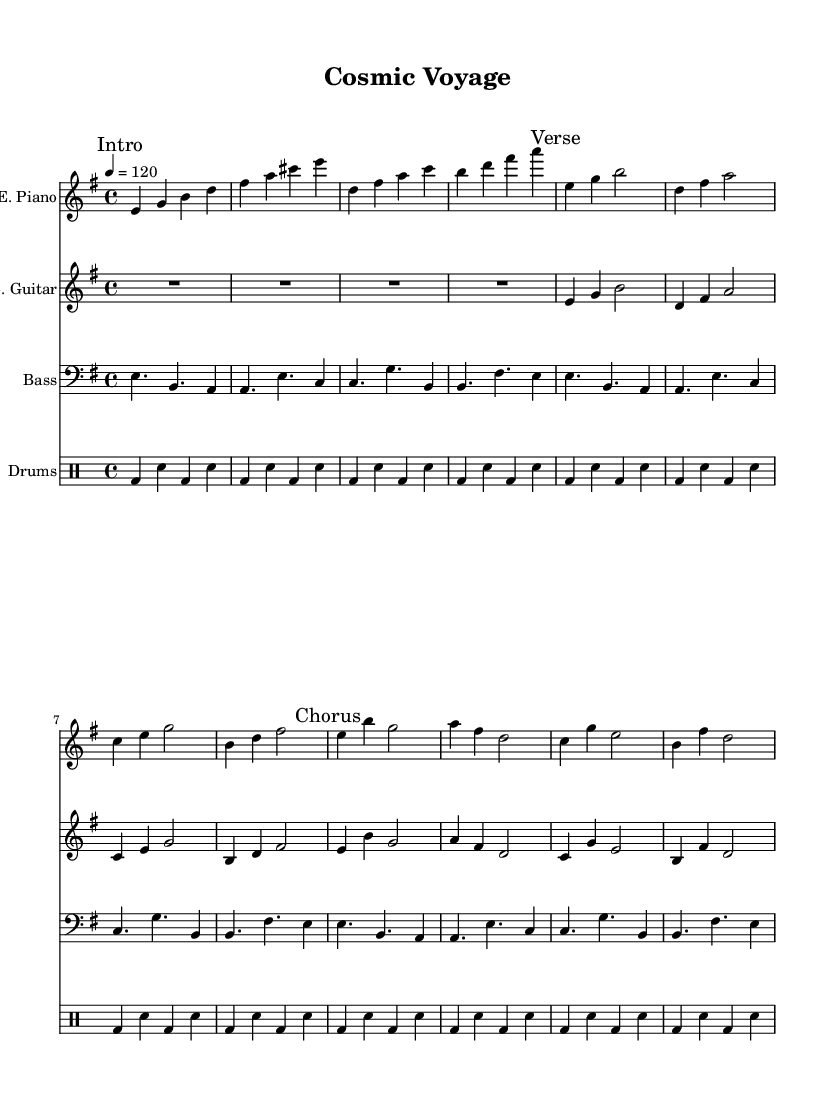What is the key signature of this music? The key signature is indicated by the presence of one sharp (F#), which corresponds to E minor.
Answer: E minor What is the time signature of this piece? The time signature is indicated at the beginning of the sheet music as 4/4, meaning there are four beats in a measure and the quarter note gets one beat.
Answer: 4/4 What is the tempo marking for this composition? The tempo marking is indicated as "4 = 120," meaning there are 120 beats per minute, which is a moderately fast tempo.
Answer: 120 How many measures are in the electric piano part? By counting the measures in the electric piano section, there are a total of 14 measures not including the repeat marks.
Answer: 14 What type of synthesizer is used in this fusion piece? The piece indicates an "E. Piano," suggesting the use of an electric piano sound, common in jazz-rock fusion genres.
Answer: Electric piano Which musical section follows the "Intro"? The section immediately following the "Intro" mark is labeled as the "Verse," showing the structure of the composition.
Answer: Verse What is the characteristic rhythm used in the drum pattern? The drum pattern consists of a repeated sequence of bass drum and snare hits, which gives it a steady, driving feel typical of fusion music.
Answer: Steady rhythmic pattern 